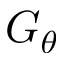Convert formula to latex. <formula><loc_0><loc_0><loc_500><loc_500>G _ { \theta }</formula> 